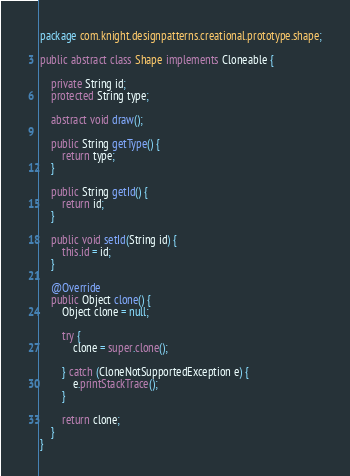Convert code to text. <code><loc_0><loc_0><loc_500><loc_500><_Java_>package com.knight.designpatterns.creational.prototype.shape;

public abstract class Shape implements Cloneable {

	private String id;
	protected String type;

	abstract void draw();

	public String getType() {
		return type;
	}

	public String getId() {
		return id;
	}

	public void setId(String id) {
		this.id = id;
	}

	@Override
	public Object clone() {
		Object clone = null;

		try {
			clone = super.clone();

		} catch (CloneNotSupportedException e) {
			e.printStackTrace();
		}

		return clone;
	}
}
</code> 